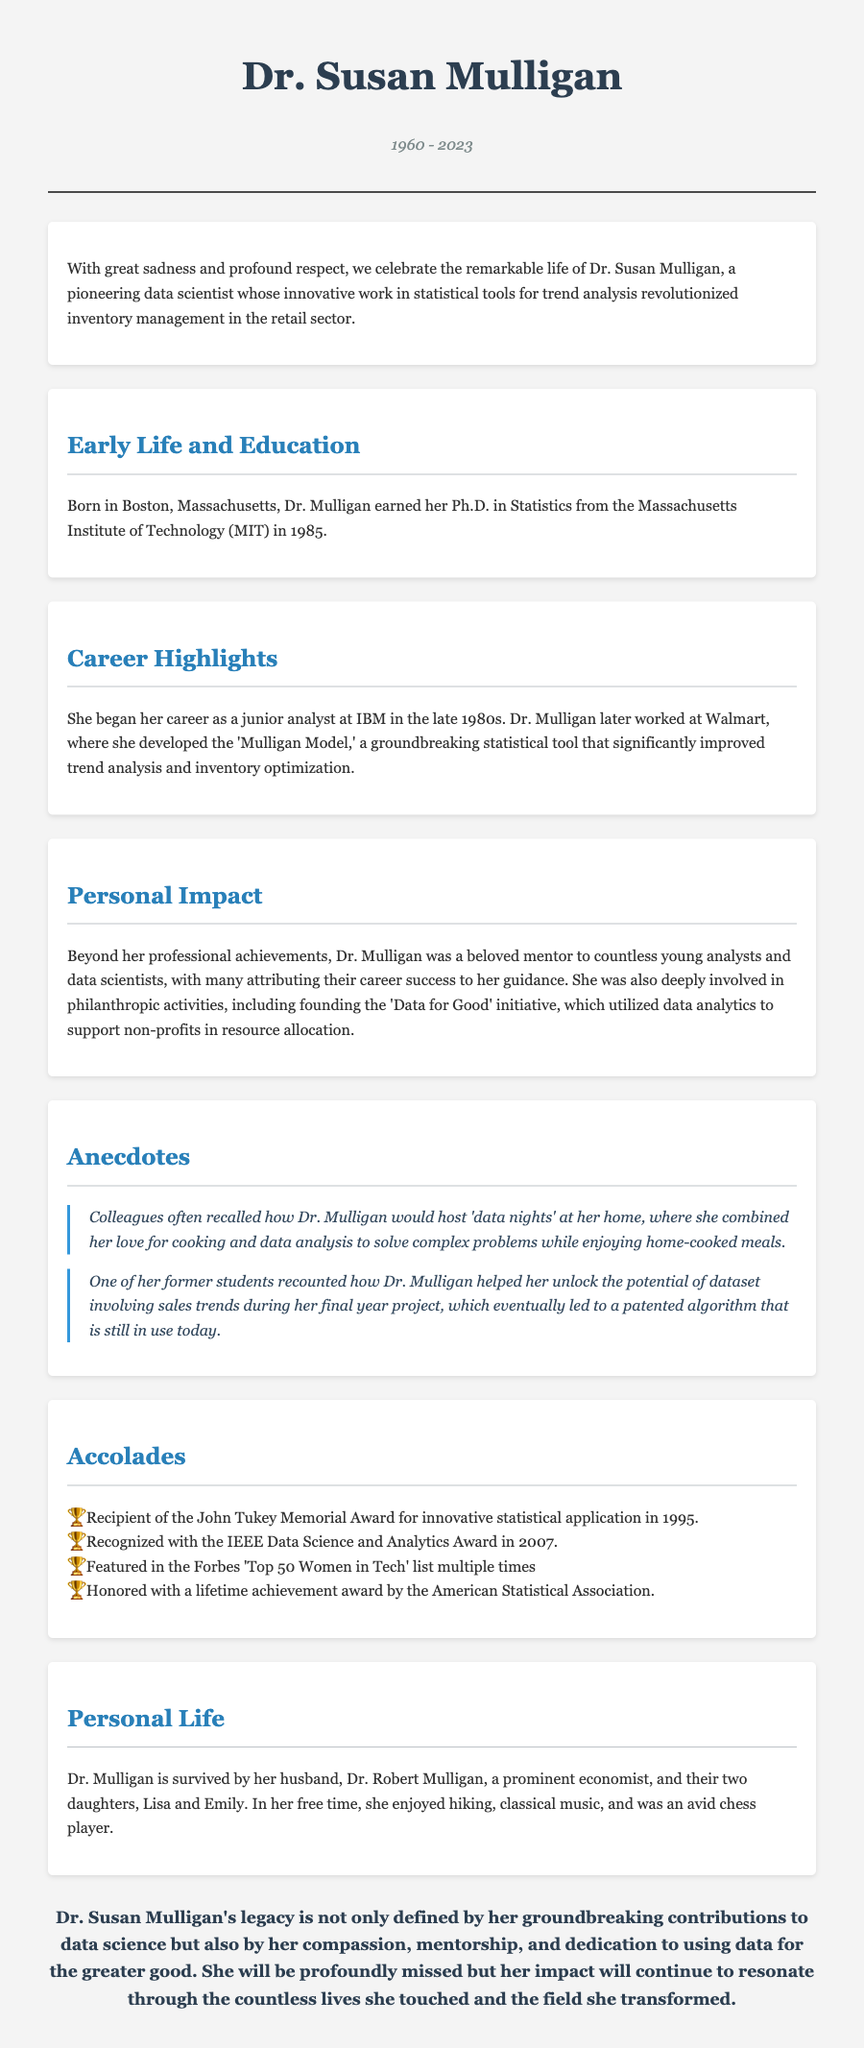What was Dr. Susan Mulligan's lifespan? The lifespan is indicated at the top of the obituary, which states "1960 - 2023."
Answer: 1960 - 2023 Which university did Dr. Mulligan earn her Ph.D. from? The document mentions that Dr. Mulligan earned her Ph.D. in Statistics from the Massachusetts Institute of Technology (MIT).
Answer: Massachusetts Institute of Technology (MIT) What is the name of the statistical tool developed by Dr. Mulligan? The tool is mentioned in the career highlights section as the 'Mulligan Model.'
Answer: Mulligan Model What philanthropic initiative did Dr. Mulligan found? The document states she founded the 'Data for Good' initiative.
Answer: Data for Good How many daughters did Dr. Mulligan have? The personal life section notes that she is survived by two daughters, Lisa and Emily.
Answer: Two What award did Dr. Mulligan receive in 1995? The accolades section lists the John Tukey Memorial Award for innovative statistical application as her achievement in 1995.
Answer: John Tukey Memorial Award What unique personal activity did Dr. Mulligan host for colleagues? The document recalls that Dr. Mulligan would host 'data nights' at her home.
Answer: Data nights What was one of Dr. Mulligan's hobbies mentioned in the obituary? The personal life section indicates that she enjoyed classical music among other hobbies.
Answer: Classical music 